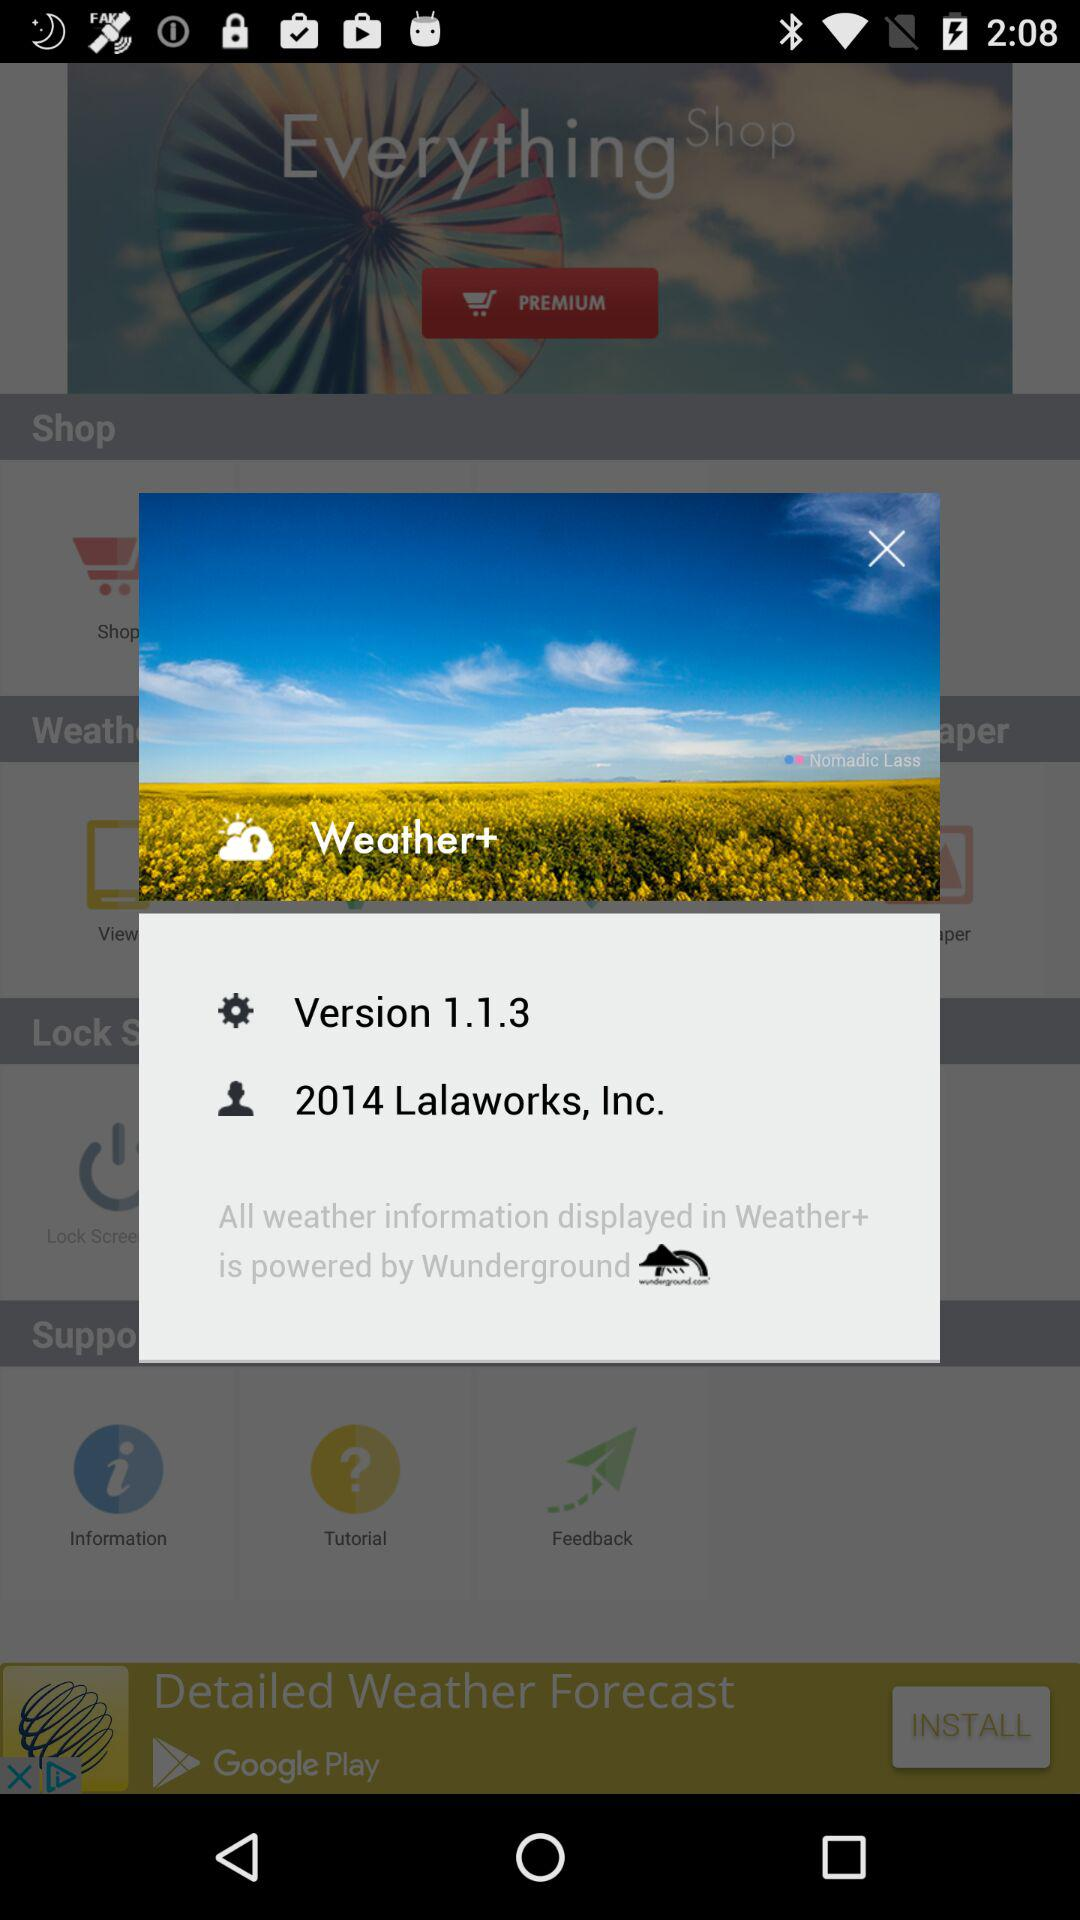What is the version number? The version number is 1.1.3. 